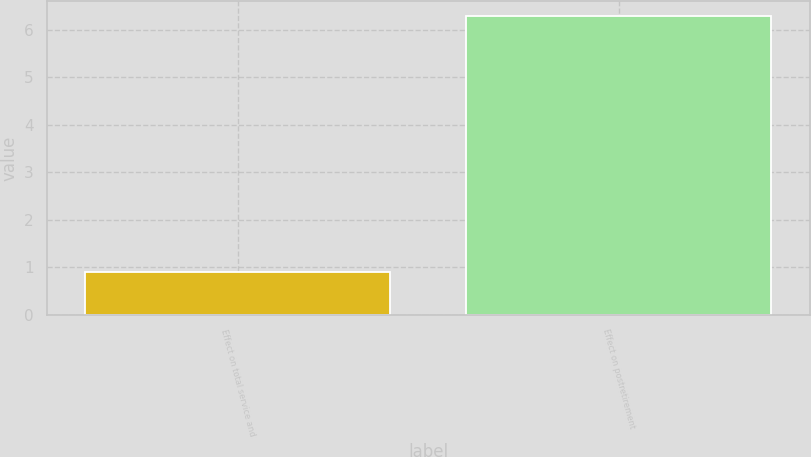<chart> <loc_0><loc_0><loc_500><loc_500><bar_chart><fcel>Effect on total service and<fcel>Effect on postretirement<nl><fcel>0.9<fcel>6.3<nl></chart> 